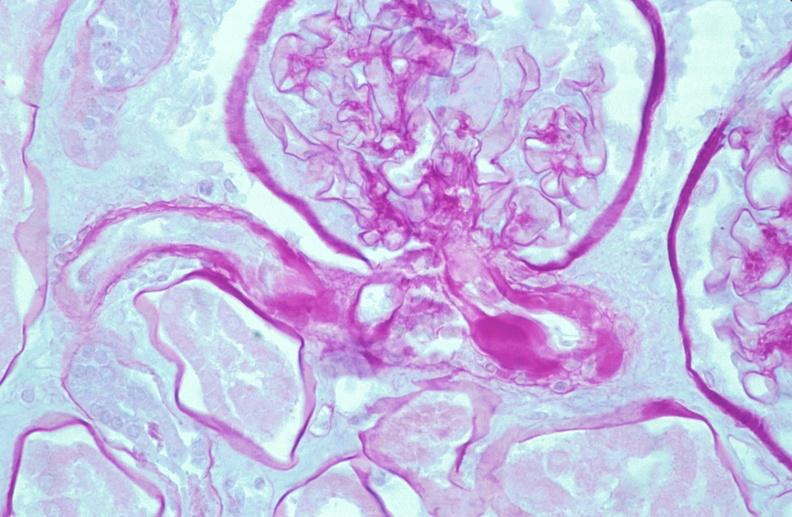where is this?
Answer the question using a single word or phrase. Urinary 